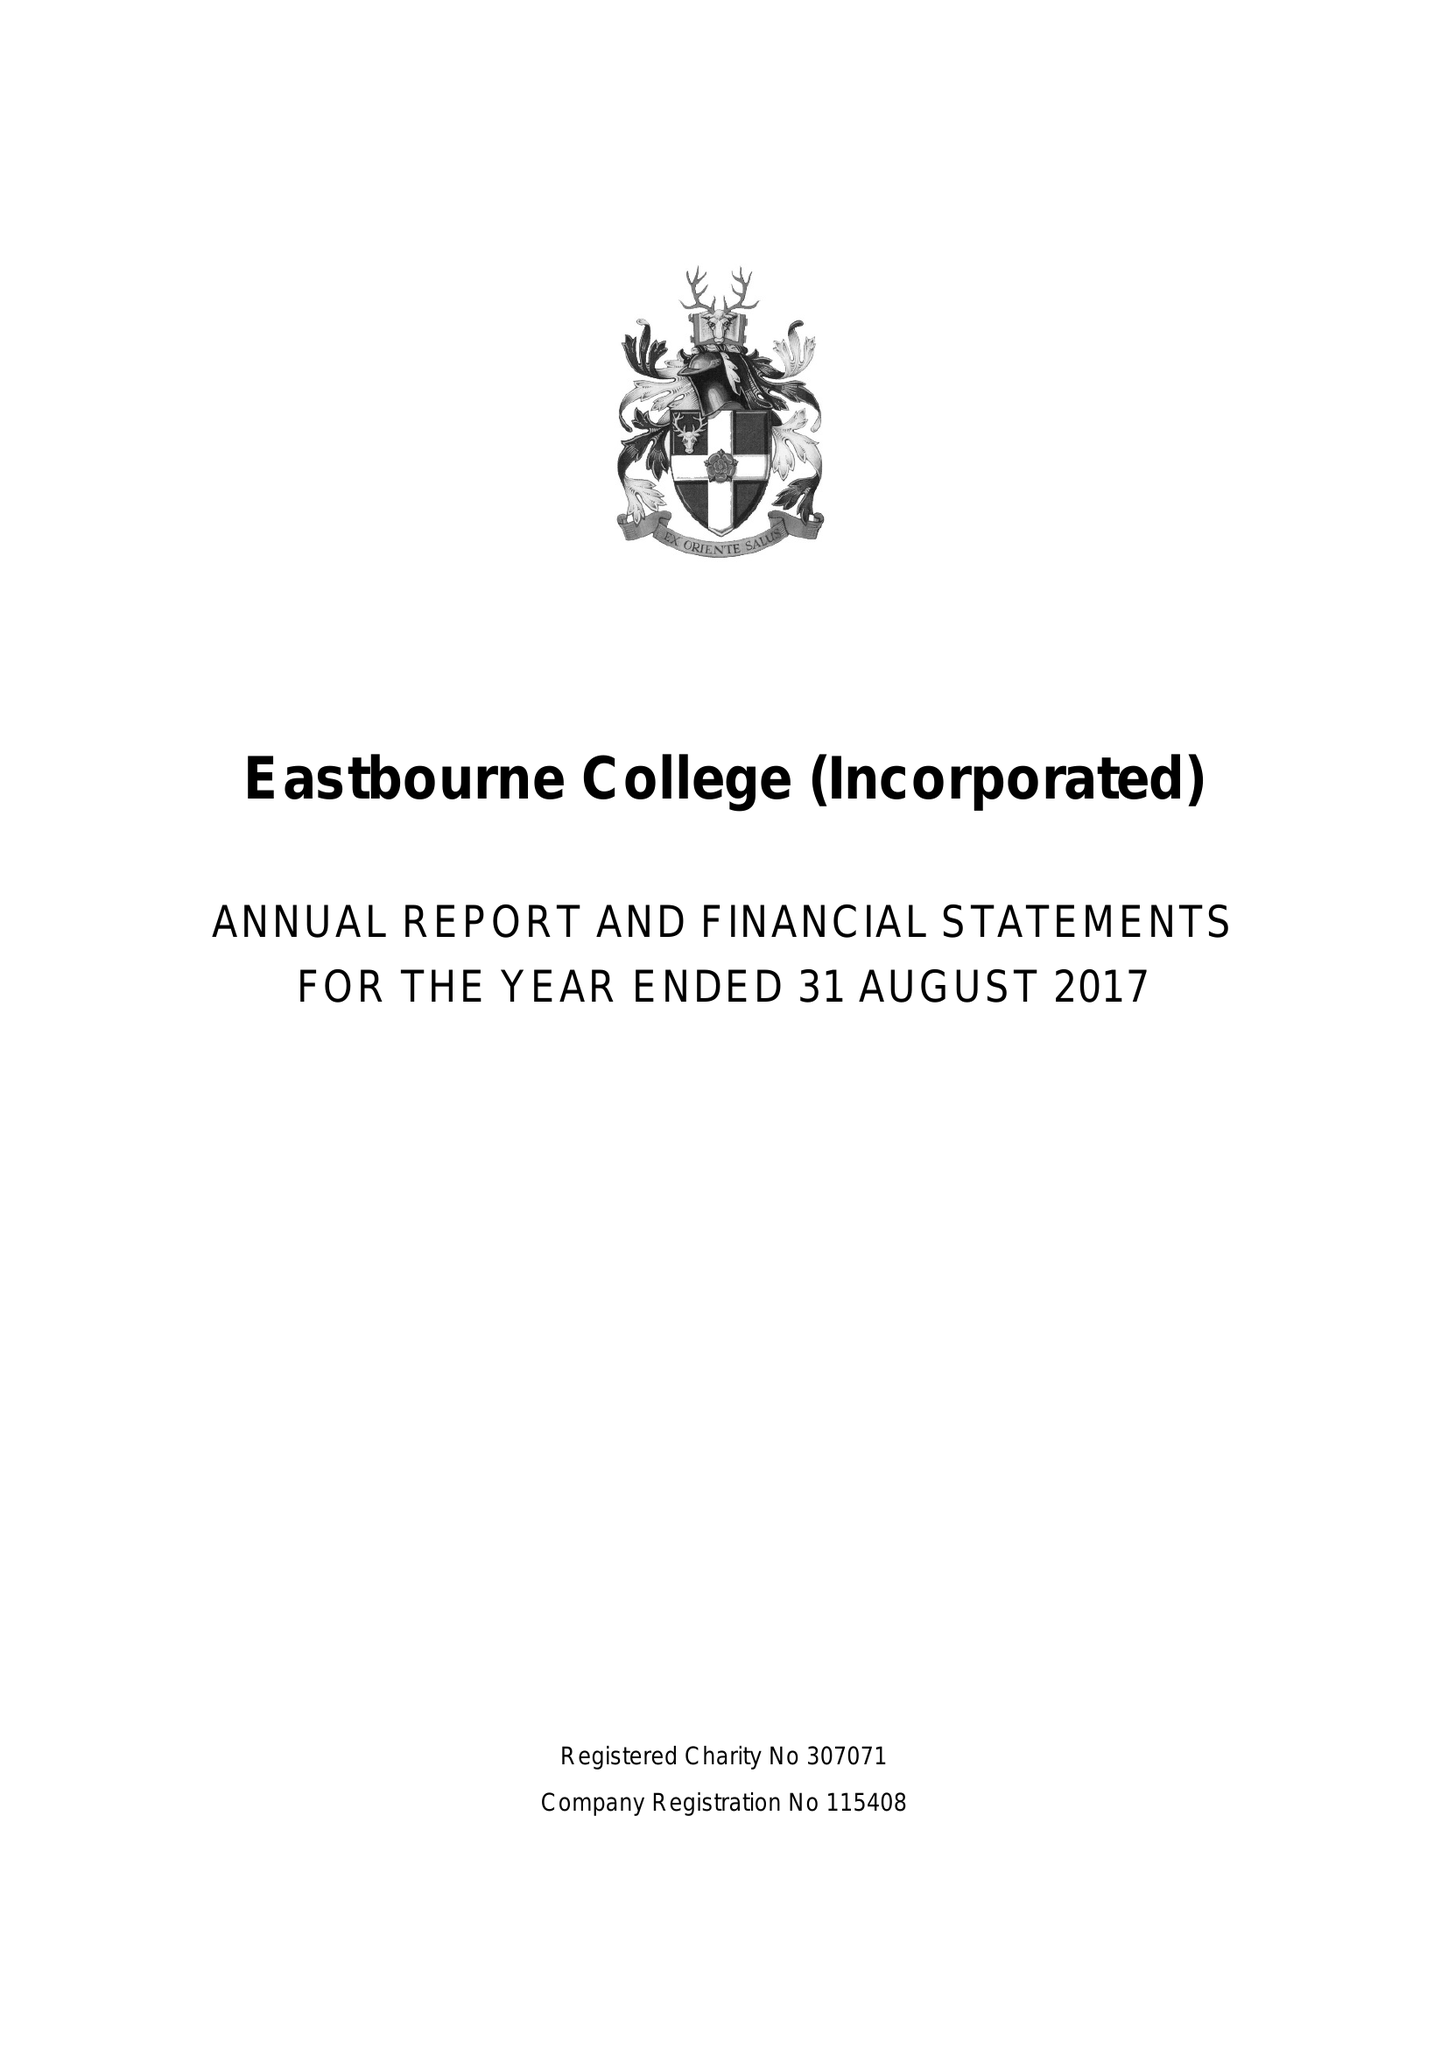What is the value for the address__postcode?
Answer the question using a single word or phrase. BN21 4JY 